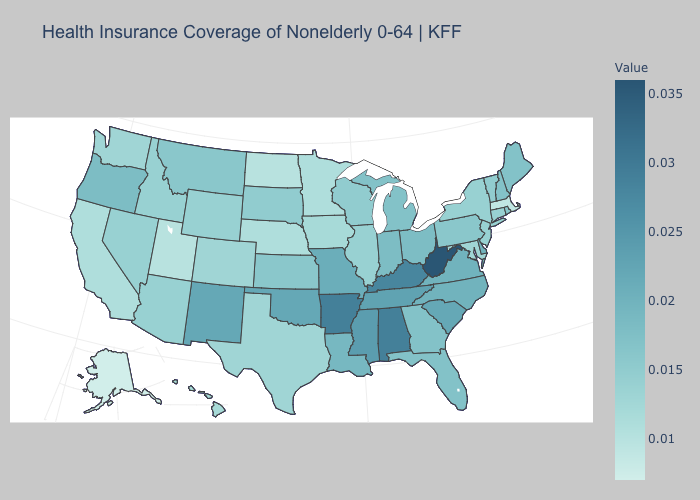Does New Mexico have the highest value in the West?
Give a very brief answer. Yes. Does Texas have the lowest value in the South?
Write a very short answer. Yes. Does Wisconsin have the lowest value in the MidWest?
Give a very brief answer. No. Does Massachusetts have the lowest value in the Northeast?
Be succinct. Yes. Does the map have missing data?
Give a very brief answer. No. Does Georgia have a higher value than Wyoming?
Short answer required. Yes. Does Tennessee have a lower value than Arkansas?
Short answer required. Yes. 